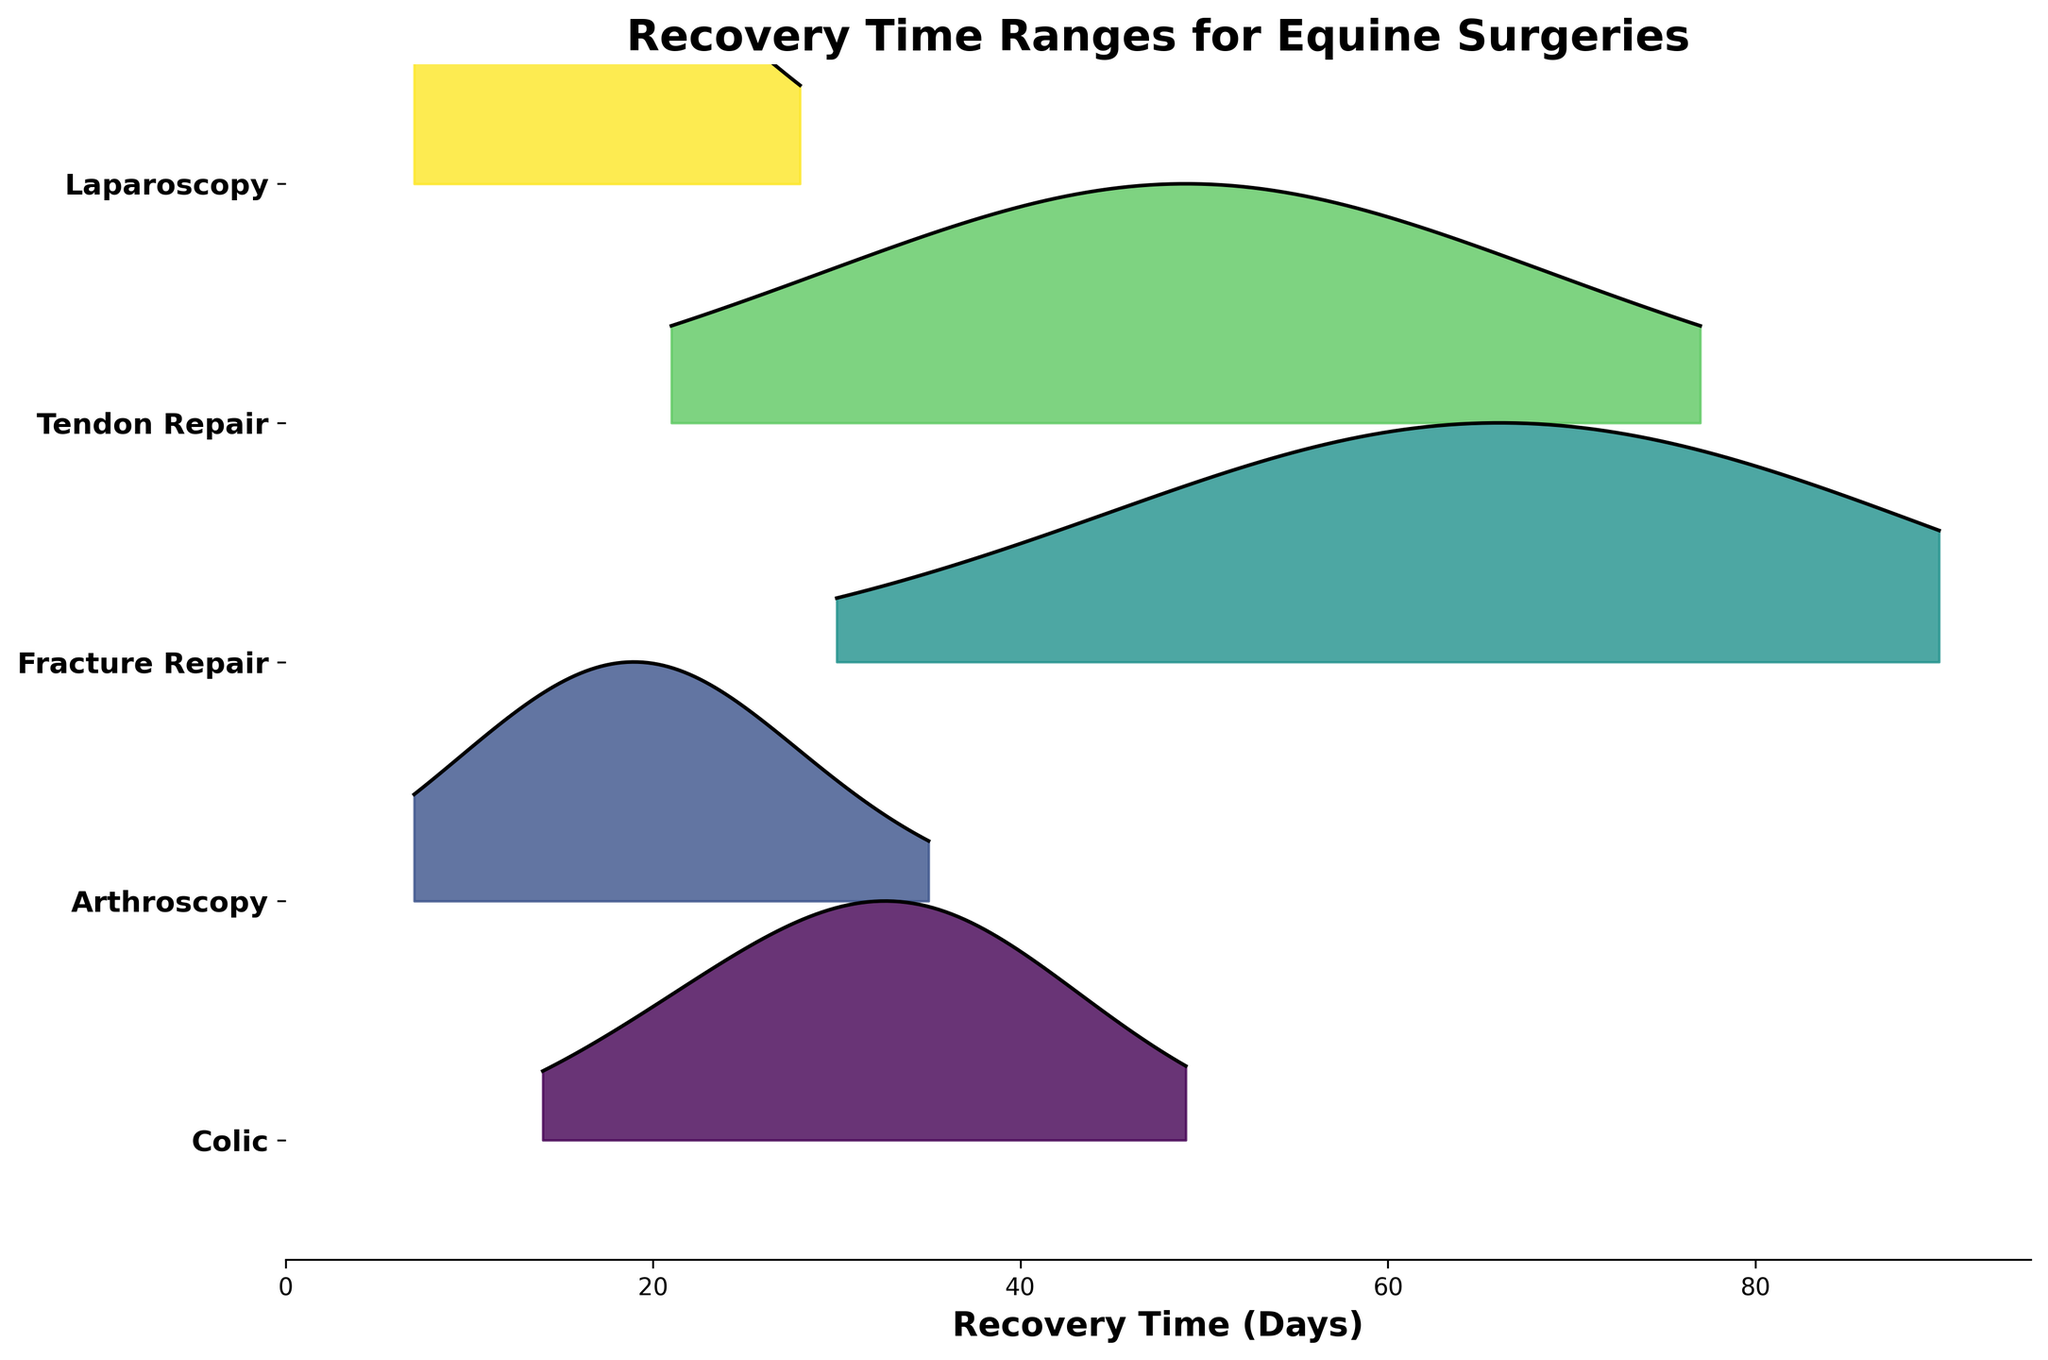What is the title of the figure? The title is typically found at the top of the figure. In this case, it reads "Recovery Time Ranges for Equine Surgeries."
Answer: Recovery Time Ranges for Equine Surgeries Name one of the surgeries with the shortest recovery time. The shortest recovery time can be identified at the leftmost end of each surgery's plot. Laparoscopy and Arthroscopy have the earliest recovery time starting at 7 days.
Answer: Laparoscopy or Arthroscopy Which surgery has the highest peak in recovery frequency? The highest peak is where the curve reaches its maximum height in the graph. Colic surgery has the most prominent peak around 35 days.
Answer: Colic What is the range of recovery days for Fracture Repair? The range is determined by the minimum and maximum values on the x-axis for Fracture Repair. It ranges from 30 to 90 days.
Answer: 30 to 90 days Which surgery has the widest range of recovery days? To determine this, observe which surgery spans the most distance on the x-axis. Fracture Repair spans from 30 to 90 days, making it the widest range.
Answer: Fracture Repair Which surgeries have a recovery time less than 10 days? By examining the x-axis, only Arthroscopy and Laparoscopy have recovery times starting at 7 days.
Answer: Arthroscopy and Laparoscopy Between Colic and Arthroscopy, which surgery tends to have longer recovery times? Comparing the x-axis distributions, Colic tends to have longer recovery times, mostly around 35 days, while Arthroscopy's peak is around 14 to 21 days.
Answer: Colic How does the recovery time distribution for Tendon Repair compare to that of Laparoscopy? Tendon Repair ranges from 21 to 77 days with a peak around 49 days, while Laparoscopy ranges from 7 to 28 days, peaking at 14 days. Tendon Repair has longer and more spread out recovery times.
Answer: Tendon Repair has a longer and more spread out recovery time What is the most common recovery time range for Laparoscopy? The most common recovery time range is where the peak of the distribution lies. For Laparoscopy, the peak is at 14 days.
Answer: 14 days Which surgery has the smallest recovery frequency around 30 days? Examine the plot lines near 30 days. For Fracture Repair, the recovery frequency is the smallest.
Answer: Fracture Repair 